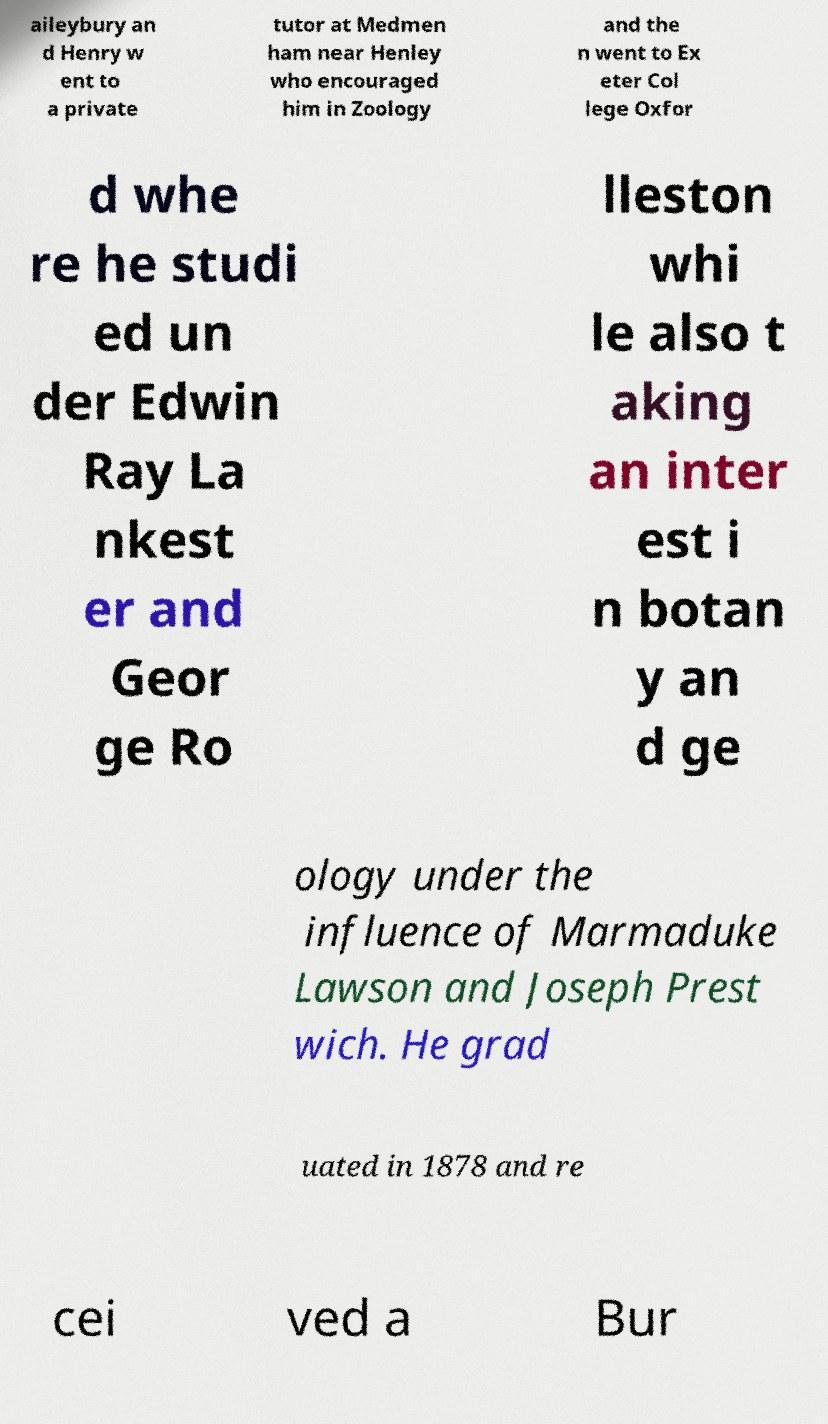I need the written content from this picture converted into text. Can you do that? aileybury an d Henry w ent to a private tutor at Medmen ham near Henley who encouraged him in Zoology and the n went to Ex eter Col lege Oxfor d whe re he studi ed un der Edwin Ray La nkest er and Geor ge Ro lleston whi le also t aking an inter est i n botan y an d ge ology under the influence of Marmaduke Lawson and Joseph Prest wich. He grad uated in 1878 and re cei ved a Bur 